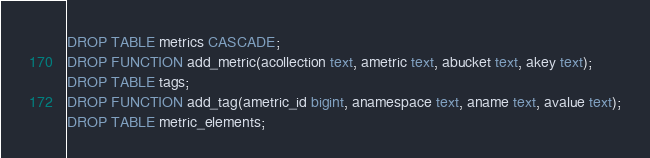Convert code to text. <code><loc_0><loc_0><loc_500><loc_500><_SQL_>DROP TABLE metrics CASCADE;
DROP FUNCTION add_metric(acollection text, ametric text, abucket text, akey text);
DROP TABLE tags;
DROP FUNCTION add_tag(ametric_id bigint, anamespace text, aname text, avalue text);
DROP TABLE metric_elements;
</code> 